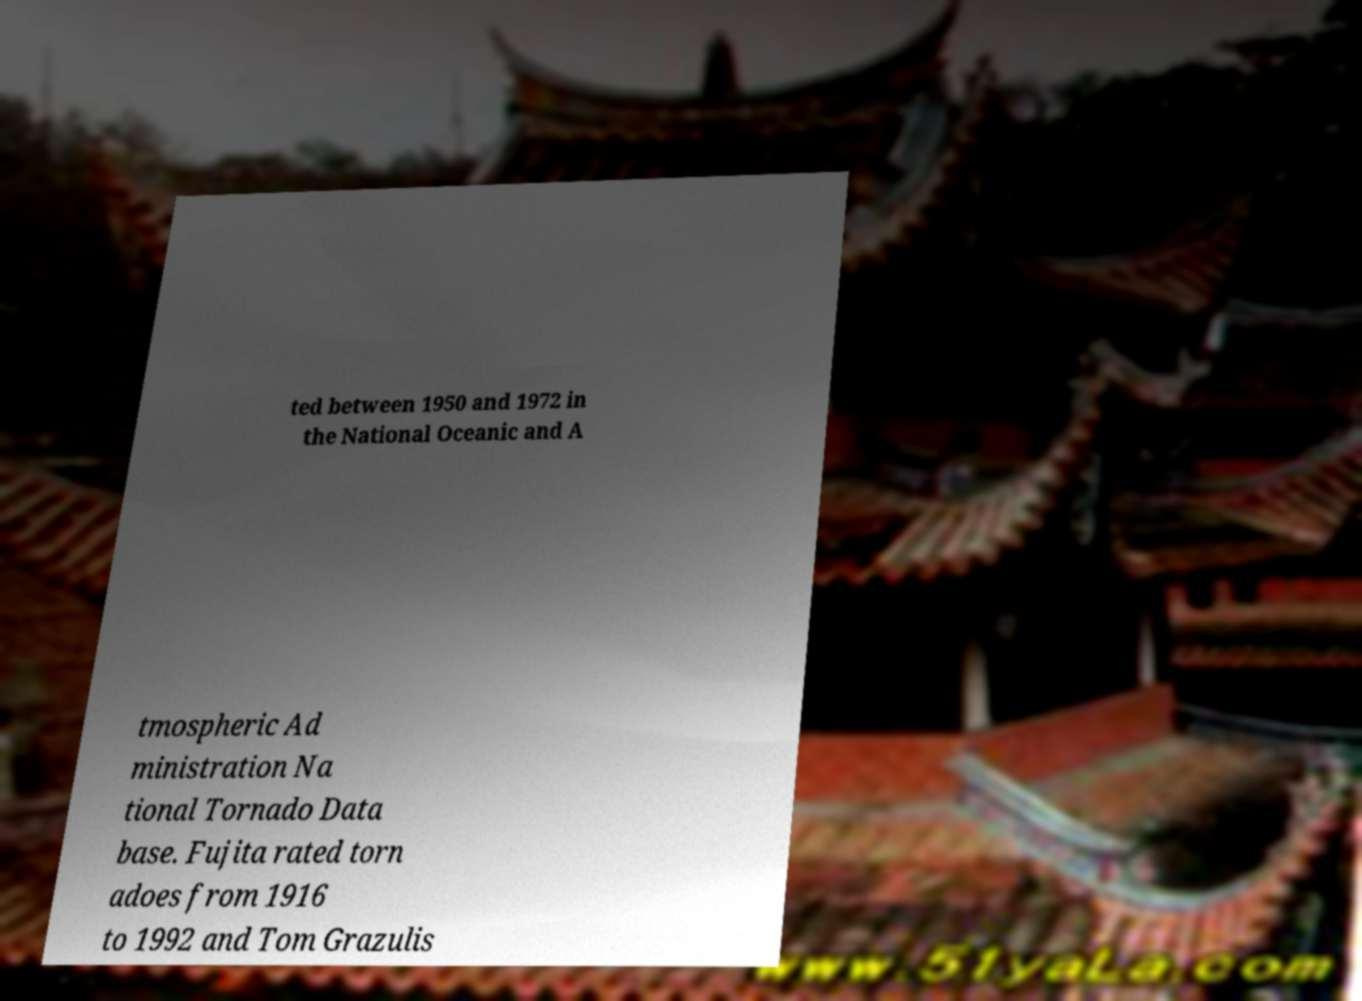Can you read and provide the text displayed in the image?This photo seems to have some interesting text. Can you extract and type it out for me? ted between 1950 and 1972 in the National Oceanic and A tmospheric Ad ministration Na tional Tornado Data base. Fujita rated torn adoes from 1916 to 1992 and Tom Grazulis 